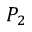<formula> <loc_0><loc_0><loc_500><loc_500>P _ { 2 }</formula> 